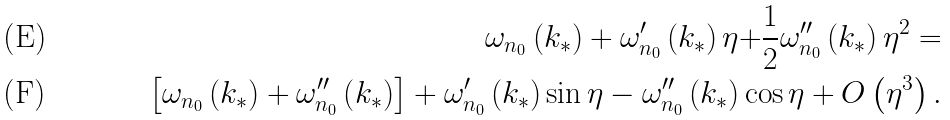<formula> <loc_0><loc_0><loc_500><loc_500>\omega _ { n _ { 0 } } \left ( k _ { \ast } \right ) + \omega _ { n _ { 0 } } ^ { \prime } \left ( k _ { \ast } \right ) \eta \mathbf { + } \frac { 1 } { 2 } \omega _ { n _ { 0 } } ^ { \prime \prime } \left ( k _ { \ast } \right ) \eta ^ { 2 } = \\ \left [ \omega _ { n _ { 0 } } \left ( k _ { \ast } \right ) + \omega _ { n _ { 0 } } ^ { \prime \prime } \left ( k _ { \ast } \right ) \right ] + \omega _ { n _ { 0 } } ^ { \prime } \left ( k _ { \ast } \right ) \sin \eta - \omega _ { n _ { 0 } } ^ { \prime \prime } \left ( k _ { \ast } \right ) \cos \eta + O \left ( \eta ^ { 3 } \right ) .</formula> 